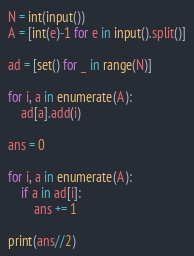<code> <loc_0><loc_0><loc_500><loc_500><_Python_>N = int(input())
A = [int(e)-1 for e in input().split()]

ad = [set() for _ in range(N)]

for i, a in enumerate(A):
    ad[a].add(i)

ans = 0

for i, a in enumerate(A):
    if a in ad[i]:
        ans += 1

print(ans//2)</code> 